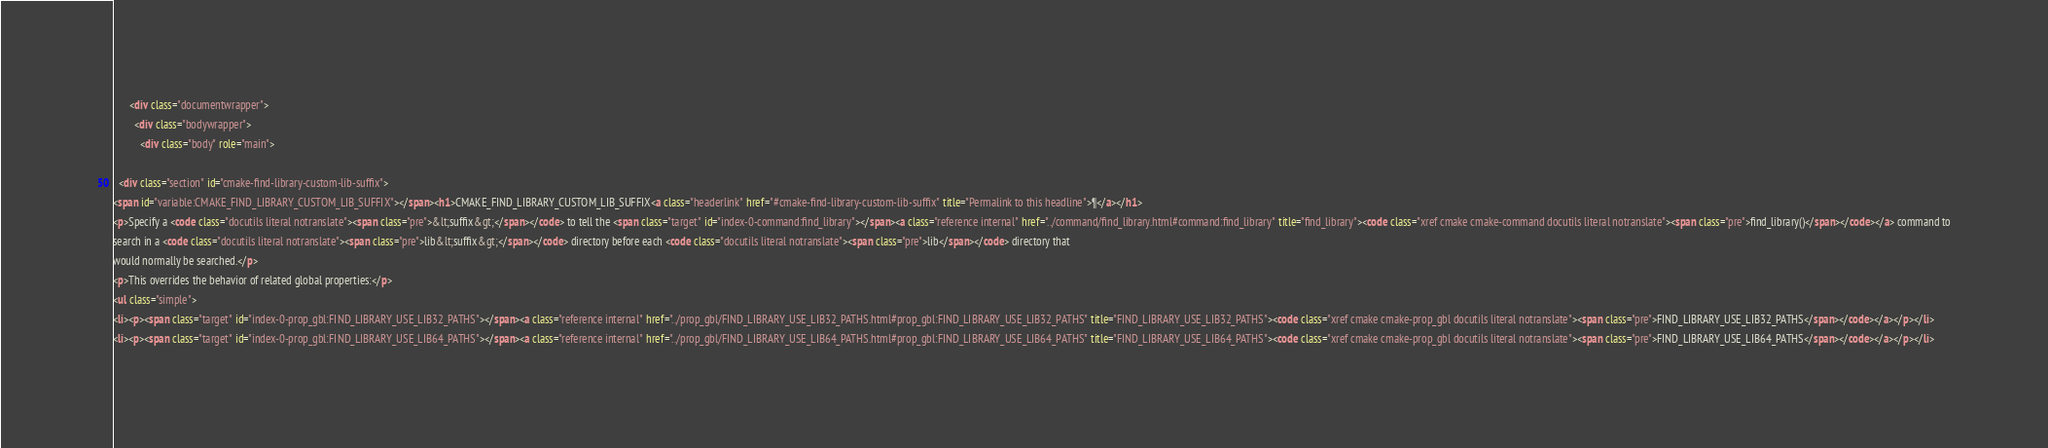Convert code to text. <code><loc_0><loc_0><loc_500><loc_500><_HTML_>      <div class="documentwrapper">
        <div class="bodywrapper">
          <div class="body" role="main">
            
  <div class="section" id="cmake-find-library-custom-lib-suffix">
<span id="variable:CMAKE_FIND_LIBRARY_CUSTOM_LIB_SUFFIX"></span><h1>CMAKE_FIND_LIBRARY_CUSTOM_LIB_SUFFIX<a class="headerlink" href="#cmake-find-library-custom-lib-suffix" title="Permalink to this headline">¶</a></h1>
<p>Specify a <code class="docutils literal notranslate"><span class="pre">&lt;suffix&gt;</span></code> to tell the <span class="target" id="index-0-command:find_library"></span><a class="reference internal" href="../command/find_library.html#command:find_library" title="find_library"><code class="xref cmake cmake-command docutils literal notranslate"><span class="pre">find_library()</span></code></a> command to
search in a <code class="docutils literal notranslate"><span class="pre">lib&lt;suffix&gt;</span></code> directory before each <code class="docutils literal notranslate"><span class="pre">lib</span></code> directory that
would normally be searched.</p>
<p>This overrides the behavior of related global properties:</p>
<ul class="simple">
<li><p><span class="target" id="index-0-prop_gbl:FIND_LIBRARY_USE_LIB32_PATHS"></span><a class="reference internal" href="../prop_gbl/FIND_LIBRARY_USE_LIB32_PATHS.html#prop_gbl:FIND_LIBRARY_USE_LIB32_PATHS" title="FIND_LIBRARY_USE_LIB32_PATHS"><code class="xref cmake cmake-prop_gbl docutils literal notranslate"><span class="pre">FIND_LIBRARY_USE_LIB32_PATHS</span></code></a></p></li>
<li><p><span class="target" id="index-0-prop_gbl:FIND_LIBRARY_USE_LIB64_PATHS"></span><a class="reference internal" href="../prop_gbl/FIND_LIBRARY_USE_LIB64_PATHS.html#prop_gbl:FIND_LIBRARY_USE_LIB64_PATHS" title="FIND_LIBRARY_USE_LIB64_PATHS"><code class="xref cmake cmake-prop_gbl docutils literal notranslate"><span class="pre">FIND_LIBRARY_USE_LIB64_PATHS</span></code></a></p></li></code> 